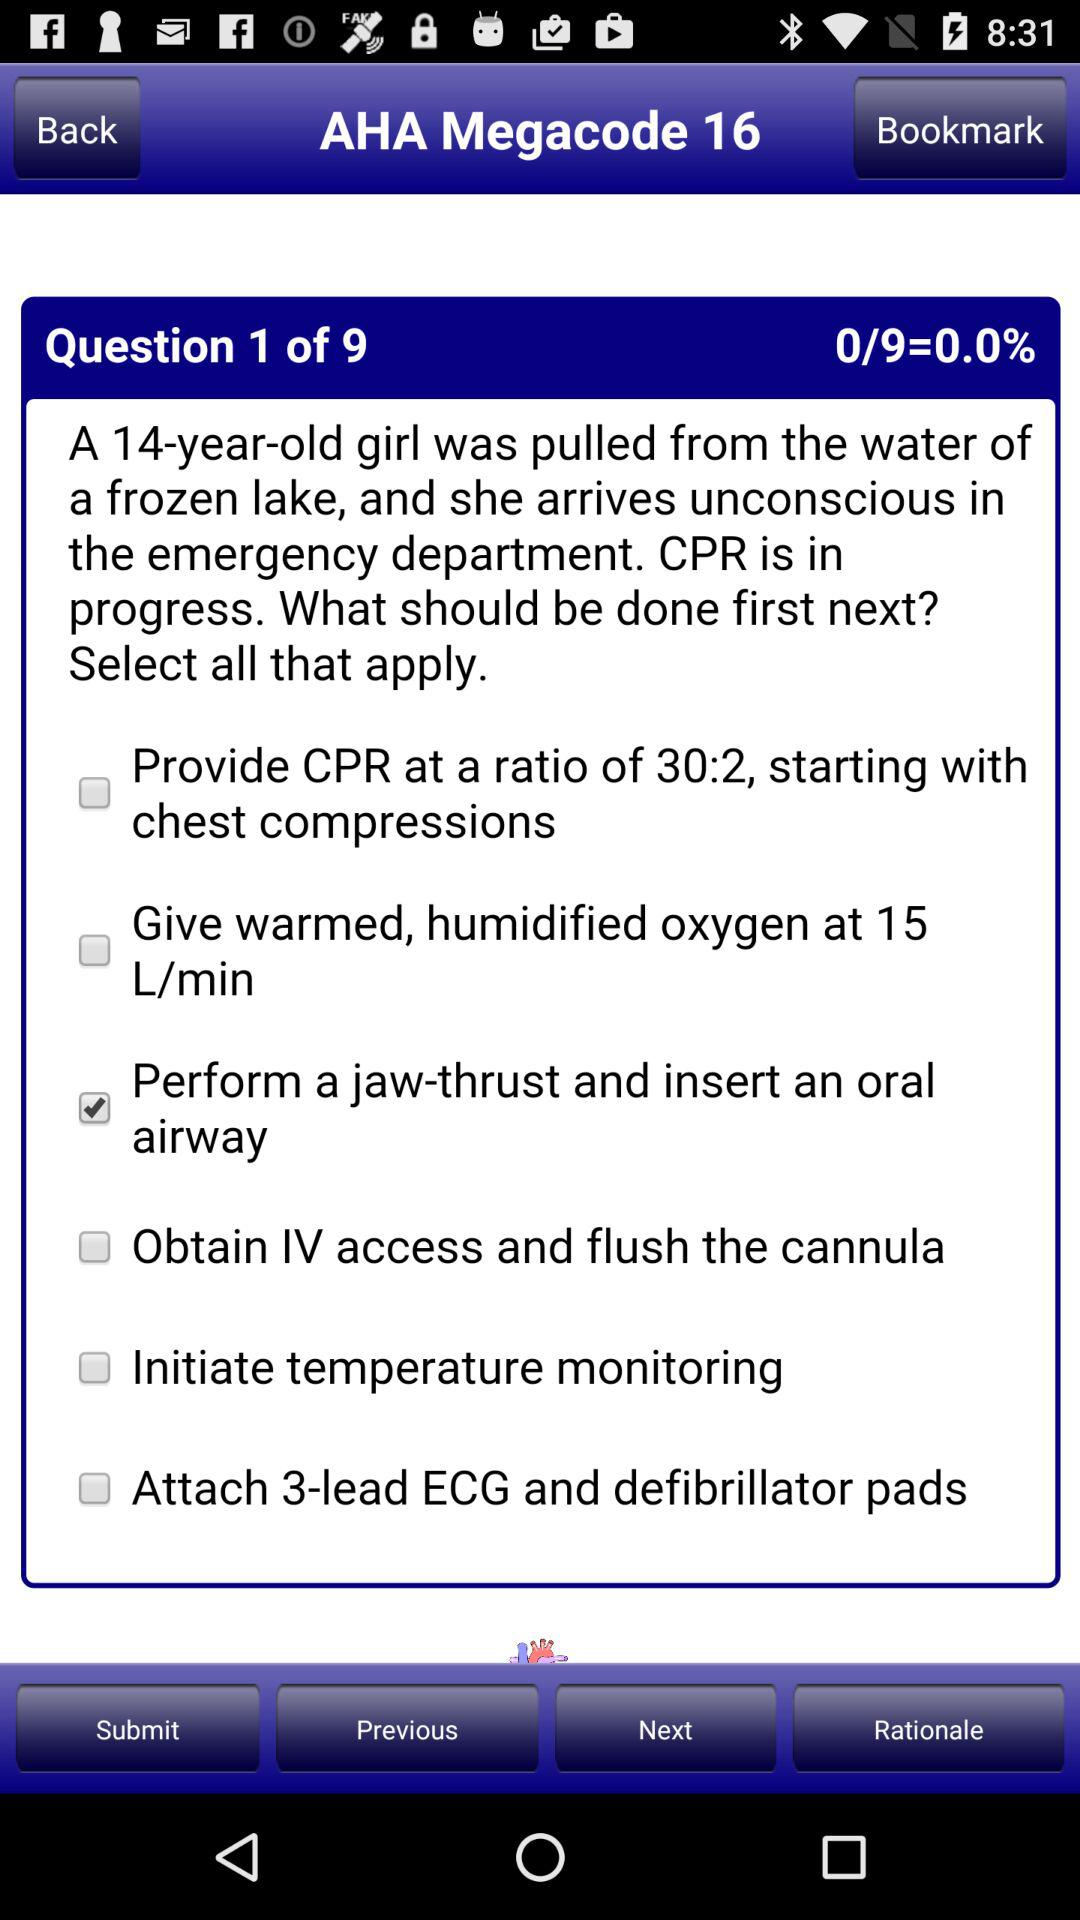Which option is selected for question number 1? The selected option for question number 1 is "Perform a jaw-thrust and insert an oral airway". 